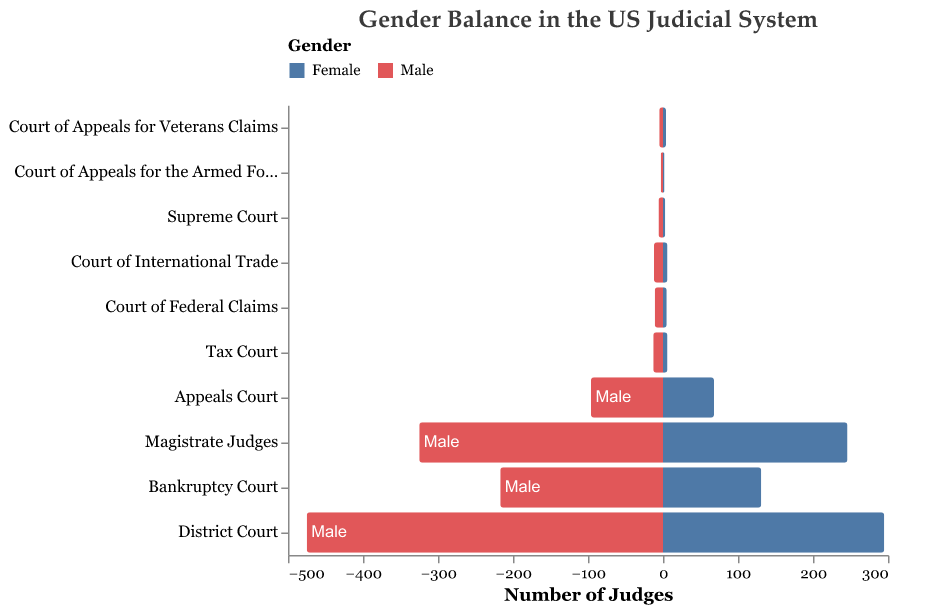what is the title of the figure? The title of the figure is displayed at the top center of the chart in 16-point Palatino font, colored in a dark gray shade. It suggests the focus of the visualization.
Answer: Gender Balance in the US Judicial System what are the two colors used to represent males and females in the figure? The bars for males are colored in a shade of blue, while females are represented with a shade of red.
Answer: Blue and Red which level has the highest number of male judges? By observing the length of the blue bars, the "District Court" level has the highest number of male judges compared to other levels.
Answer: District Court which level has the smallest discrepancy between male and female judges? To find the smallest discrepancy, we need to check the levels with blue and red bars closest in length. The "Court of Appeals for Veterans Claims" shows the smallest difference between male and female judges with 5 males and 4 females.
Answer: Court of Appeals for Veterans Claims what is the total number of judges at the Tax Court level? Adding the number of male and female judges at the "Tax Court" level, we get 13 (male) + 6 (female) = 19 judges in total.
Answer: 19 which level has a closer gender balance, Bankruptcy Court or Magistrate Judges? To determine closer gender balance, we compare the proportions of male to female judges. Bankruptcy Court has 217 males and 131 females, while Magistrate Judges have 325 males and 246 females. The proportion of male-to-female is closer in Magistrate Judges.
Answer: Magistrate Judges how many more male than female judges are in the Appeals Court level? Subtract the number of female judges from the number of male judges at the "Appeals Court" level: 96 (male) - 68 (female) = 28 more male judges.
Answer: 28 which level has the lowest number of total judges, and how many are there? By summing the male and female judges at each level, the "Court of Appeals for the Armed Forces" has the lowest total with 3 (male) + 2 (female) = 5 judges.
Answer: Court of Appeals for the Armed Forces, 5 what is the average number of female judges across all levels? First, sum the number of female judges across all levels: 3 + 68 + 295 + 246 + 131 + 6 + 6 + 5 + 4 + 2 = 766. Then, divide by the number of levels (10): 766 / 10 = 76.6.
Answer: 76.6 